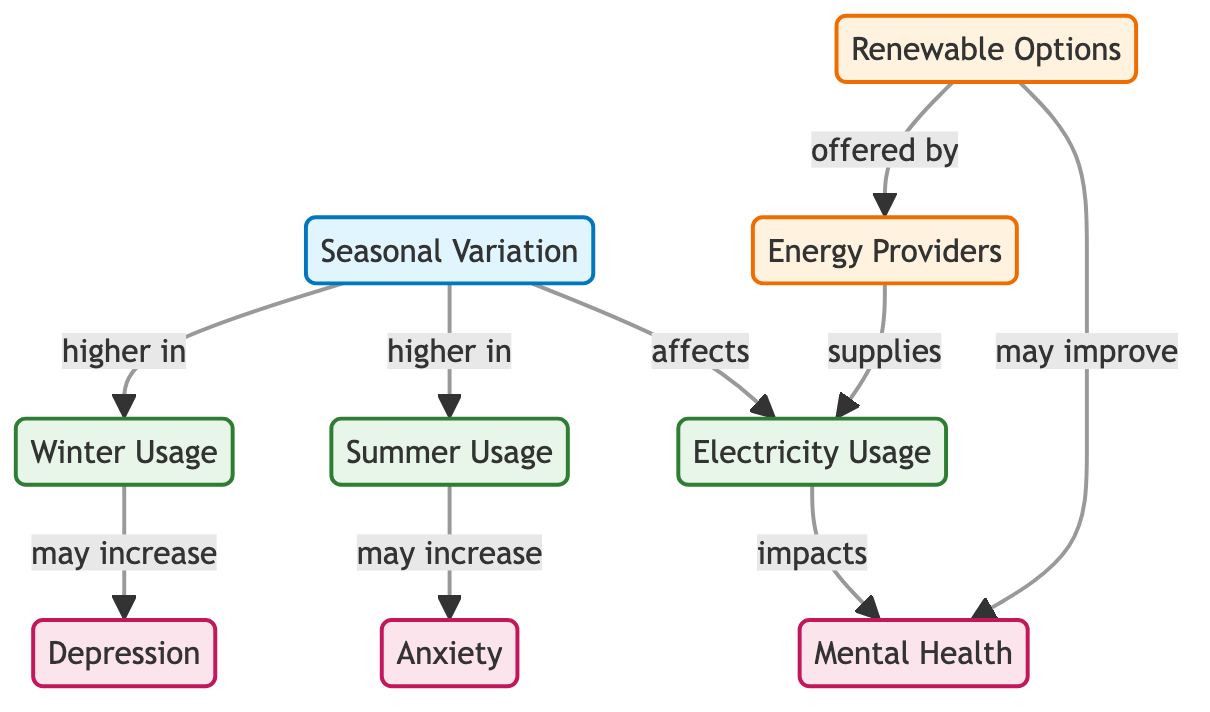What does seasonal variation affect? The diagram indicates that seasonal variation affects electricity usage. This is shown by the direct connection between the "Seasonal Variation" node and the "Electricity Usage" node.
Answer: Electricity Usage Which type of usage is higher in summer? In the diagram, the arrow pointing from "Seasonal Variation" to "Summer Usage" implies that summer usage is higher as a result of seasonal variation.
Answer: Summer Usage What mental health issue may increase with summer usage? The connection from "Summer Usage" to "Anxiety" reveals that increased summer usage may lead to heightened anxiety levels among residents.
Answer: Anxiety How many nodes represent mental health issues in the diagram? There are three nodes directly related to mental health: "Mental Health," "Anxiety," and "Depression." Counting these nodes gives a total of three.
Answer: Three What is one recommended option that may improve mental health? The diagram shows that "Renewable Options" offered by energy providers may improve mental health. This is indicated by the arrow leading from "Renewable Options" to "Mental Health."
Answer: Renewable Options Which season's usage may increase depression? The arrow from "Winter Usage" to "Depression" in the diagram indicates that depression may increase with winter usage.
Answer: Winter Usage How many connections are there leading from seasonal variation? The "Seasonal Variation" node directly connects to three different nodes: "Electricity Usage," "Summer Usage," and "Winter Usage." This results in a total of three connections.
Answer: Three Which nodes are specifically related to energy providers? The diagram highlights two nodes related to energy providers: "Energy Providers" and "Renewable Options." The connection shows that renewable options are offered by energy providers.
Answer: Energy Providers, Renewable Options What relationship does winter usage have with mental health? The diagram illustrates a direct influence where winter usage may lead to an increase in depression, indicated by the arrow linking "Winter Usage" to "Depression."
Answer: May increase Depression 